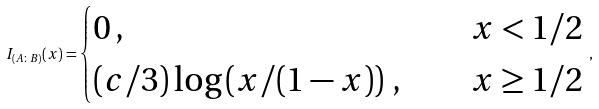<formula> <loc_0><loc_0><loc_500><loc_500>I _ { ( A \colon B ) } ( x ) = \begin{cases} 0 \, , \quad & x < 1 / 2 \\ ( c / 3 ) \log \left ( x / ( 1 - x ) \right ) \, , \quad & x \geq 1 / 2 \end{cases} \, ,</formula> 